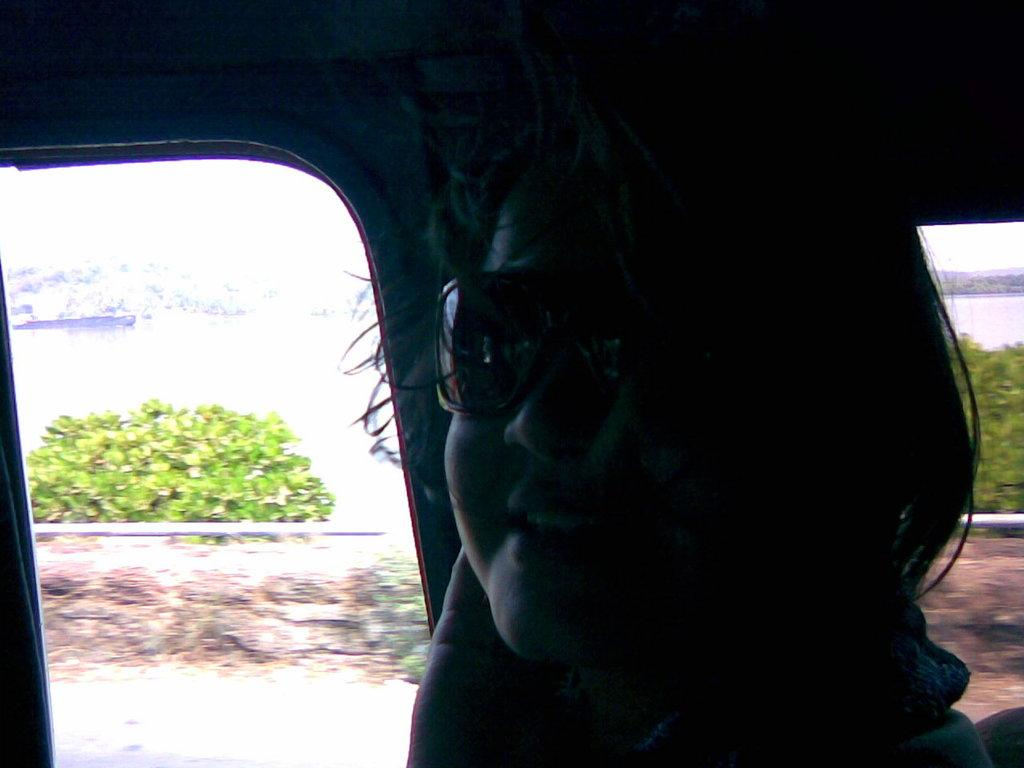Where was the image taken? The image was taken inside a vehicle. What can be seen in the foreground of the image? There is a person wearing spectacles in the foreground of the image. What type of vegetation is visible in the background of the image? There are plants, trees, and a wall in the background of the image. Can you describe any man-made structures in the background of the image? Yes, there is a pipe in the background of the image. What organization is responsible for the statement made by the apparatus in the image? There is no organization or statement made by an apparatus in the image; it features a person wearing spectacles inside a vehicle with a background that includes plants, trees, a wall, and a pipe. 